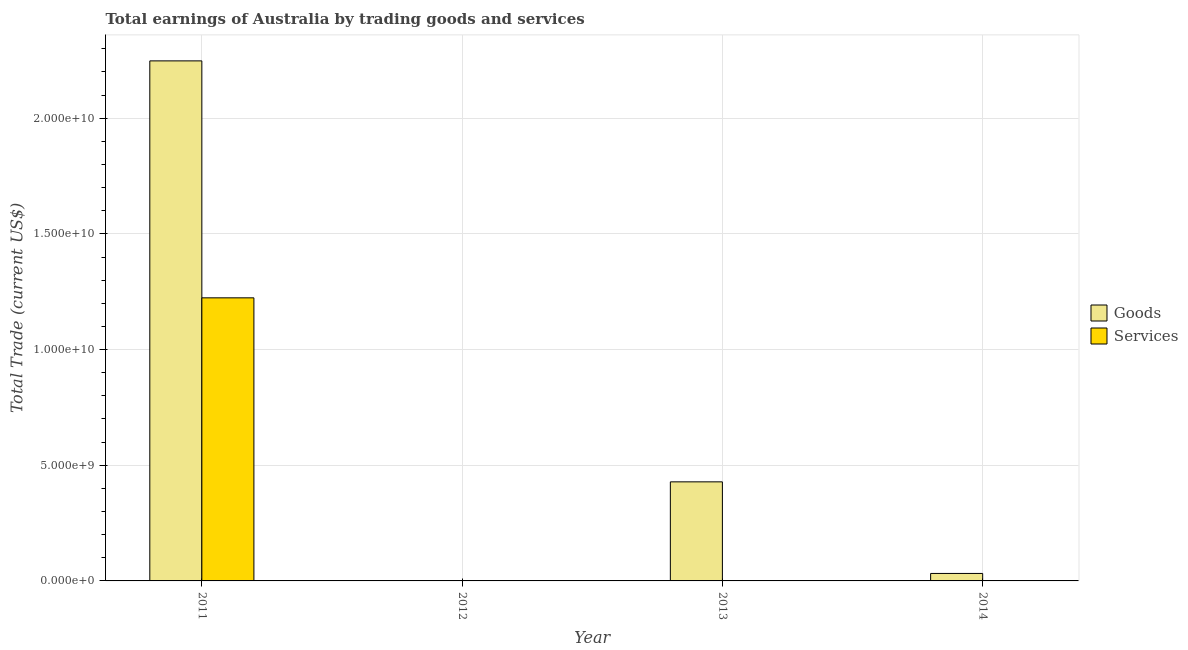Are the number of bars on each tick of the X-axis equal?
Ensure brevity in your answer.  No. How many bars are there on the 1st tick from the right?
Provide a short and direct response. 1. What is the label of the 3rd group of bars from the left?
Provide a succinct answer. 2013. In how many cases, is the number of bars for a given year not equal to the number of legend labels?
Offer a terse response. 3. What is the amount earned by trading services in 2013?
Make the answer very short. 0. Across all years, what is the maximum amount earned by trading services?
Ensure brevity in your answer.  1.22e+1. What is the total amount earned by trading services in the graph?
Your answer should be compact. 1.22e+1. What is the average amount earned by trading services per year?
Provide a succinct answer. 3.06e+09. In the year 2011, what is the difference between the amount earned by trading services and amount earned by trading goods?
Make the answer very short. 0. In how many years, is the amount earned by trading services greater than 11000000000 US$?
Offer a very short reply. 1. What is the ratio of the amount earned by trading goods in 2011 to that in 2014?
Your response must be concise. 69.52. Is the difference between the amount earned by trading goods in 2011 and 2014 greater than the difference between the amount earned by trading services in 2011 and 2014?
Ensure brevity in your answer.  No. What is the difference between the highest and the second highest amount earned by trading goods?
Make the answer very short. 1.82e+1. What is the difference between the highest and the lowest amount earned by trading goods?
Your response must be concise. 2.25e+1. How many bars are there?
Offer a very short reply. 4. Are all the bars in the graph horizontal?
Ensure brevity in your answer.  No. Does the graph contain grids?
Ensure brevity in your answer.  Yes. Where does the legend appear in the graph?
Your answer should be compact. Center right. How many legend labels are there?
Offer a very short reply. 2. What is the title of the graph?
Your answer should be very brief. Total earnings of Australia by trading goods and services. What is the label or title of the X-axis?
Offer a very short reply. Year. What is the label or title of the Y-axis?
Your answer should be compact. Total Trade (current US$). What is the Total Trade (current US$) in Goods in 2011?
Your response must be concise. 2.25e+1. What is the Total Trade (current US$) in Services in 2011?
Your answer should be very brief. 1.22e+1. What is the Total Trade (current US$) of Goods in 2013?
Make the answer very short. 4.28e+09. What is the Total Trade (current US$) of Services in 2013?
Offer a terse response. 0. What is the Total Trade (current US$) of Goods in 2014?
Provide a succinct answer. 3.23e+08. What is the Total Trade (current US$) in Services in 2014?
Offer a terse response. 0. Across all years, what is the maximum Total Trade (current US$) of Goods?
Your answer should be compact. 2.25e+1. Across all years, what is the maximum Total Trade (current US$) in Services?
Provide a short and direct response. 1.22e+1. What is the total Total Trade (current US$) in Goods in the graph?
Offer a very short reply. 2.71e+1. What is the total Total Trade (current US$) of Services in the graph?
Give a very brief answer. 1.22e+1. What is the difference between the Total Trade (current US$) of Goods in 2011 and that in 2013?
Your response must be concise. 1.82e+1. What is the difference between the Total Trade (current US$) of Goods in 2011 and that in 2014?
Your answer should be compact. 2.22e+1. What is the difference between the Total Trade (current US$) in Goods in 2013 and that in 2014?
Your response must be concise. 3.96e+09. What is the average Total Trade (current US$) of Goods per year?
Your answer should be very brief. 6.77e+09. What is the average Total Trade (current US$) in Services per year?
Give a very brief answer. 3.06e+09. In the year 2011, what is the difference between the Total Trade (current US$) in Goods and Total Trade (current US$) in Services?
Offer a terse response. 1.02e+1. What is the ratio of the Total Trade (current US$) of Goods in 2011 to that in 2013?
Make the answer very short. 5.25. What is the ratio of the Total Trade (current US$) in Goods in 2011 to that in 2014?
Your answer should be compact. 69.52. What is the ratio of the Total Trade (current US$) in Goods in 2013 to that in 2014?
Make the answer very short. 13.24. What is the difference between the highest and the second highest Total Trade (current US$) of Goods?
Ensure brevity in your answer.  1.82e+1. What is the difference between the highest and the lowest Total Trade (current US$) of Goods?
Give a very brief answer. 2.25e+1. What is the difference between the highest and the lowest Total Trade (current US$) in Services?
Give a very brief answer. 1.22e+1. 